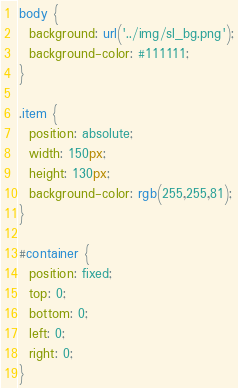<code> <loc_0><loc_0><loc_500><loc_500><_CSS_>body {
  background: url('../img/sl_bg.png');
  background-color: #111111;
}

.item {
  position: absolute;
  width: 150px;
  height: 130px;
  background-color: rgb(255,255,81);
}

#container {
  position: fixed;
  top: 0;
  bottom: 0;
  left: 0;
  right: 0;
}</code> 